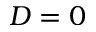Convert formula to latex. <formula><loc_0><loc_0><loc_500><loc_500>D = 0</formula> 